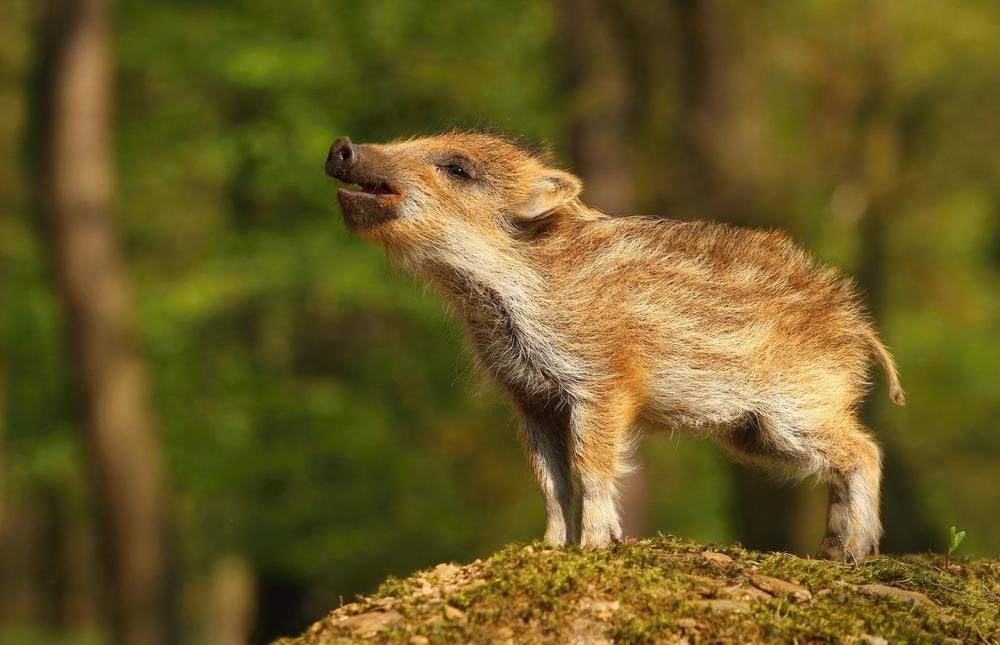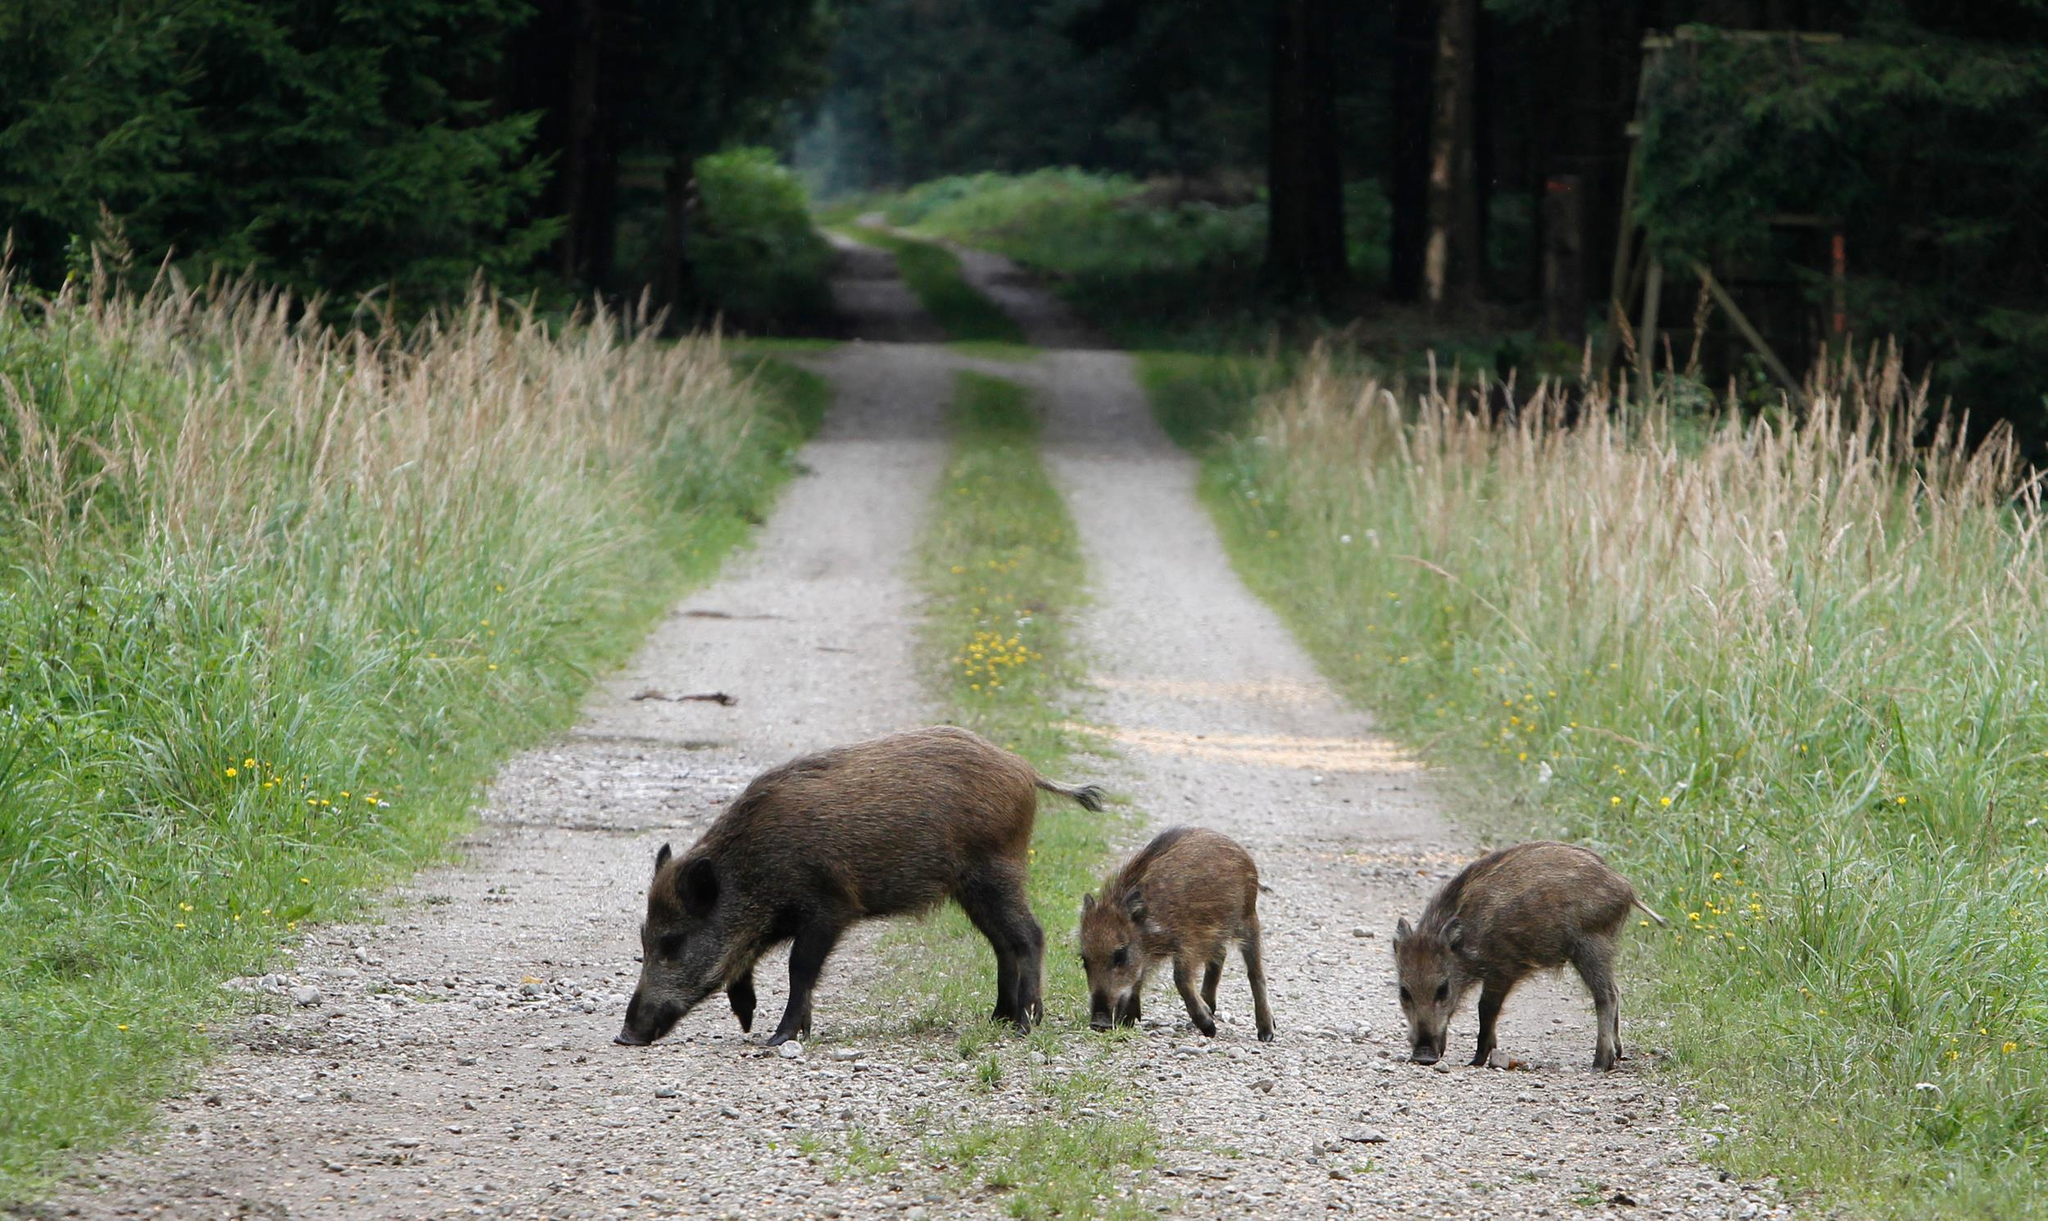The first image is the image on the left, the second image is the image on the right. Assess this claim about the two images: "The right image contains exactly two pigs.". Correct or not? Answer yes or no. No. The first image is the image on the left, the second image is the image on the right. Considering the images on both sides, is "The combined images contain three pigs, and the right image contains twice as many pigs as the left image." valid? Answer yes or no. No. 